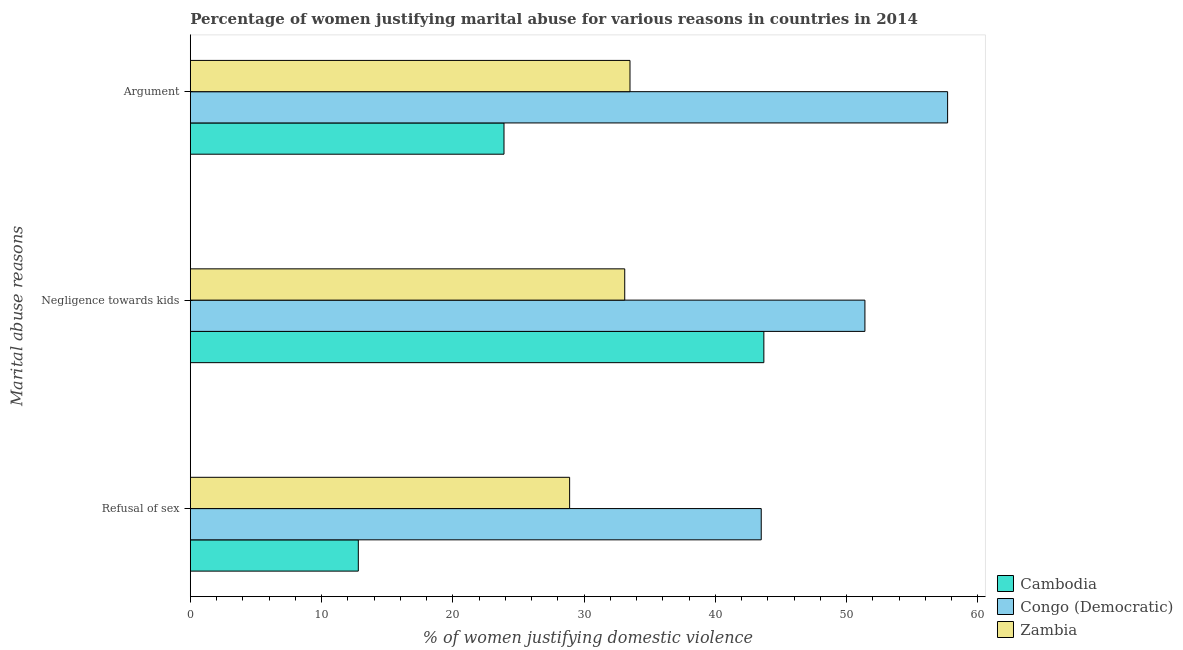Are the number of bars on each tick of the Y-axis equal?
Keep it short and to the point. Yes. How many bars are there on the 1st tick from the top?
Your response must be concise. 3. What is the label of the 1st group of bars from the top?
Provide a short and direct response. Argument. What is the percentage of women justifying domestic violence due to refusal of sex in Congo (Democratic)?
Provide a short and direct response. 43.5. Across all countries, what is the maximum percentage of women justifying domestic violence due to negligence towards kids?
Provide a succinct answer. 51.4. Across all countries, what is the minimum percentage of women justifying domestic violence due to arguments?
Keep it short and to the point. 23.9. In which country was the percentage of women justifying domestic violence due to refusal of sex maximum?
Provide a succinct answer. Congo (Democratic). In which country was the percentage of women justifying domestic violence due to refusal of sex minimum?
Offer a very short reply. Cambodia. What is the total percentage of women justifying domestic violence due to negligence towards kids in the graph?
Your response must be concise. 128.2. What is the difference between the percentage of women justifying domestic violence due to negligence towards kids in Zambia and that in Cambodia?
Your response must be concise. -10.6. What is the average percentage of women justifying domestic violence due to negligence towards kids per country?
Your answer should be compact. 42.73. What is the difference between the percentage of women justifying domestic violence due to arguments and percentage of women justifying domestic violence due to negligence towards kids in Zambia?
Give a very brief answer. 0.4. What is the ratio of the percentage of women justifying domestic violence due to refusal of sex in Cambodia to that in Zambia?
Provide a succinct answer. 0.44. Is the percentage of women justifying domestic violence due to negligence towards kids in Zambia less than that in Cambodia?
Your response must be concise. Yes. What is the difference between the highest and the second highest percentage of women justifying domestic violence due to negligence towards kids?
Make the answer very short. 7.7. What is the difference between the highest and the lowest percentage of women justifying domestic violence due to arguments?
Your response must be concise. 33.8. Is the sum of the percentage of women justifying domestic violence due to refusal of sex in Cambodia and Congo (Democratic) greater than the maximum percentage of women justifying domestic violence due to negligence towards kids across all countries?
Your response must be concise. Yes. What does the 1st bar from the top in Argument represents?
Your answer should be compact. Zambia. What does the 2nd bar from the bottom in Refusal of sex represents?
Your response must be concise. Congo (Democratic). How many bars are there?
Make the answer very short. 9. Are all the bars in the graph horizontal?
Make the answer very short. Yes. How many countries are there in the graph?
Your response must be concise. 3. Are the values on the major ticks of X-axis written in scientific E-notation?
Make the answer very short. No. Does the graph contain any zero values?
Offer a terse response. No. Does the graph contain grids?
Ensure brevity in your answer.  No. How are the legend labels stacked?
Provide a short and direct response. Vertical. What is the title of the graph?
Provide a succinct answer. Percentage of women justifying marital abuse for various reasons in countries in 2014. What is the label or title of the X-axis?
Offer a very short reply. % of women justifying domestic violence. What is the label or title of the Y-axis?
Keep it short and to the point. Marital abuse reasons. What is the % of women justifying domestic violence in Cambodia in Refusal of sex?
Your response must be concise. 12.8. What is the % of women justifying domestic violence of Congo (Democratic) in Refusal of sex?
Provide a short and direct response. 43.5. What is the % of women justifying domestic violence in Zambia in Refusal of sex?
Your answer should be very brief. 28.9. What is the % of women justifying domestic violence in Cambodia in Negligence towards kids?
Your response must be concise. 43.7. What is the % of women justifying domestic violence of Congo (Democratic) in Negligence towards kids?
Keep it short and to the point. 51.4. What is the % of women justifying domestic violence of Zambia in Negligence towards kids?
Offer a terse response. 33.1. What is the % of women justifying domestic violence in Cambodia in Argument?
Make the answer very short. 23.9. What is the % of women justifying domestic violence in Congo (Democratic) in Argument?
Offer a terse response. 57.7. What is the % of women justifying domestic violence in Zambia in Argument?
Your response must be concise. 33.5. Across all Marital abuse reasons, what is the maximum % of women justifying domestic violence of Cambodia?
Give a very brief answer. 43.7. Across all Marital abuse reasons, what is the maximum % of women justifying domestic violence of Congo (Democratic)?
Offer a very short reply. 57.7. Across all Marital abuse reasons, what is the maximum % of women justifying domestic violence of Zambia?
Give a very brief answer. 33.5. Across all Marital abuse reasons, what is the minimum % of women justifying domestic violence in Cambodia?
Provide a succinct answer. 12.8. Across all Marital abuse reasons, what is the minimum % of women justifying domestic violence of Congo (Democratic)?
Your answer should be compact. 43.5. Across all Marital abuse reasons, what is the minimum % of women justifying domestic violence of Zambia?
Ensure brevity in your answer.  28.9. What is the total % of women justifying domestic violence of Cambodia in the graph?
Offer a terse response. 80.4. What is the total % of women justifying domestic violence in Congo (Democratic) in the graph?
Your answer should be very brief. 152.6. What is the total % of women justifying domestic violence of Zambia in the graph?
Provide a succinct answer. 95.5. What is the difference between the % of women justifying domestic violence in Cambodia in Refusal of sex and that in Negligence towards kids?
Your response must be concise. -30.9. What is the difference between the % of women justifying domestic violence in Congo (Democratic) in Refusal of sex and that in Argument?
Offer a very short reply. -14.2. What is the difference between the % of women justifying domestic violence in Zambia in Refusal of sex and that in Argument?
Make the answer very short. -4.6. What is the difference between the % of women justifying domestic violence of Cambodia in Negligence towards kids and that in Argument?
Your answer should be very brief. 19.8. What is the difference between the % of women justifying domestic violence in Cambodia in Refusal of sex and the % of women justifying domestic violence in Congo (Democratic) in Negligence towards kids?
Your answer should be compact. -38.6. What is the difference between the % of women justifying domestic violence of Cambodia in Refusal of sex and the % of women justifying domestic violence of Zambia in Negligence towards kids?
Your answer should be compact. -20.3. What is the difference between the % of women justifying domestic violence in Congo (Democratic) in Refusal of sex and the % of women justifying domestic violence in Zambia in Negligence towards kids?
Your answer should be very brief. 10.4. What is the difference between the % of women justifying domestic violence in Cambodia in Refusal of sex and the % of women justifying domestic violence in Congo (Democratic) in Argument?
Provide a short and direct response. -44.9. What is the difference between the % of women justifying domestic violence of Cambodia in Refusal of sex and the % of women justifying domestic violence of Zambia in Argument?
Make the answer very short. -20.7. What is the difference between the % of women justifying domestic violence of Congo (Democratic) in Refusal of sex and the % of women justifying domestic violence of Zambia in Argument?
Provide a succinct answer. 10. What is the difference between the % of women justifying domestic violence in Cambodia in Negligence towards kids and the % of women justifying domestic violence in Congo (Democratic) in Argument?
Provide a succinct answer. -14. What is the difference between the % of women justifying domestic violence of Congo (Democratic) in Negligence towards kids and the % of women justifying domestic violence of Zambia in Argument?
Your answer should be very brief. 17.9. What is the average % of women justifying domestic violence of Cambodia per Marital abuse reasons?
Make the answer very short. 26.8. What is the average % of women justifying domestic violence in Congo (Democratic) per Marital abuse reasons?
Offer a terse response. 50.87. What is the average % of women justifying domestic violence of Zambia per Marital abuse reasons?
Provide a short and direct response. 31.83. What is the difference between the % of women justifying domestic violence of Cambodia and % of women justifying domestic violence of Congo (Democratic) in Refusal of sex?
Provide a short and direct response. -30.7. What is the difference between the % of women justifying domestic violence in Cambodia and % of women justifying domestic violence in Zambia in Refusal of sex?
Give a very brief answer. -16.1. What is the difference between the % of women justifying domestic violence in Congo (Democratic) and % of women justifying domestic violence in Zambia in Refusal of sex?
Give a very brief answer. 14.6. What is the difference between the % of women justifying domestic violence of Cambodia and % of women justifying domestic violence of Congo (Democratic) in Negligence towards kids?
Your answer should be compact. -7.7. What is the difference between the % of women justifying domestic violence in Congo (Democratic) and % of women justifying domestic violence in Zambia in Negligence towards kids?
Offer a very short reply. 18.3. What is the difference between the % of women justifying domestic violence in Cambodia and % of women justifying domestic violence in Congo (Democratic) in Argument?
Make the answer very short. -33.8. What is the difference between the % of women justifying domestic violence in Cambodia and % of women justifying domestic violence in Zambia in Argument?
Offer a very short reply. -9.6. What is the difference between the % of women justifying domestic violence in Congo (Democratic) and % of women justifying domestic violence in Zambia in Argument?
Provide a short and direct response. 24.2. What is the ratio of the % of women justifying domestic violence in Cambodia in Refusal of sex to that in Negligence towards kids?
Make the answer very short. 0.29. What is the ratio of the % of women justifying domestic violence of Congo (Democratic) in Refusal of sex to that in Negligence towards kids?
Your answer should be compact. 0.85. What is the ratio of the % of women justifying domestic violence in Zambia in Refusal of sex to that in Negligence towards kids?
Offer a terse response. 0.87. What is the ratio of the % of women justifying domestic violence in Cambodia in Refusal of sex to that in Argument?
Keep it short and to the point. 0.54. What is the ratio of the % of women justifying domestic violence of Congo (Democratic) in Refusal of sex to that in Argument?
Ensure brevity in your answer.  0.75. What is the ratio of the % of women justifying domestic violence in Zambia in Refusal of sex to that in Argument?
Give a very brief answer. 0.86. What is the ratio of the % of women justifying domestic violence in Cambodia in Negligence towards kids to that in Argument?
Your answer should be compact. 1.83. What is the ratio of the % of women justifying domestic violence in Congo (Democratic) in Negligence towards kids to that in Argument?
Offer a very short reply. 0.89. What is the difference between the highest and the second highest % of women justifying domestic violence in Cambodia?
Provide a short and direct response. 19.8. What is the difference between the highest and the second highest % of women justifying domestic violence in Congo (Democratic)?
Ensure brevity in your answer.  6.3. What is the difference between the highest and the second highest % of women justifying domestic violence in Zambia?
Provide a succinct answer. 0.4. What is the difference between the highest and the lowest % of women justifying domestic violence in Cambodia?
Keep it short and to the point. 30.9. What is the difference between the highest and the lowest % of women justifying domestic violence of Congo (Democratic)?
Keep it short and to the point. 14.2. What is the difference between the highest and the lowest % of women justifying domestic violence in Zambia?
Keep it short and to the point. 4.6. 